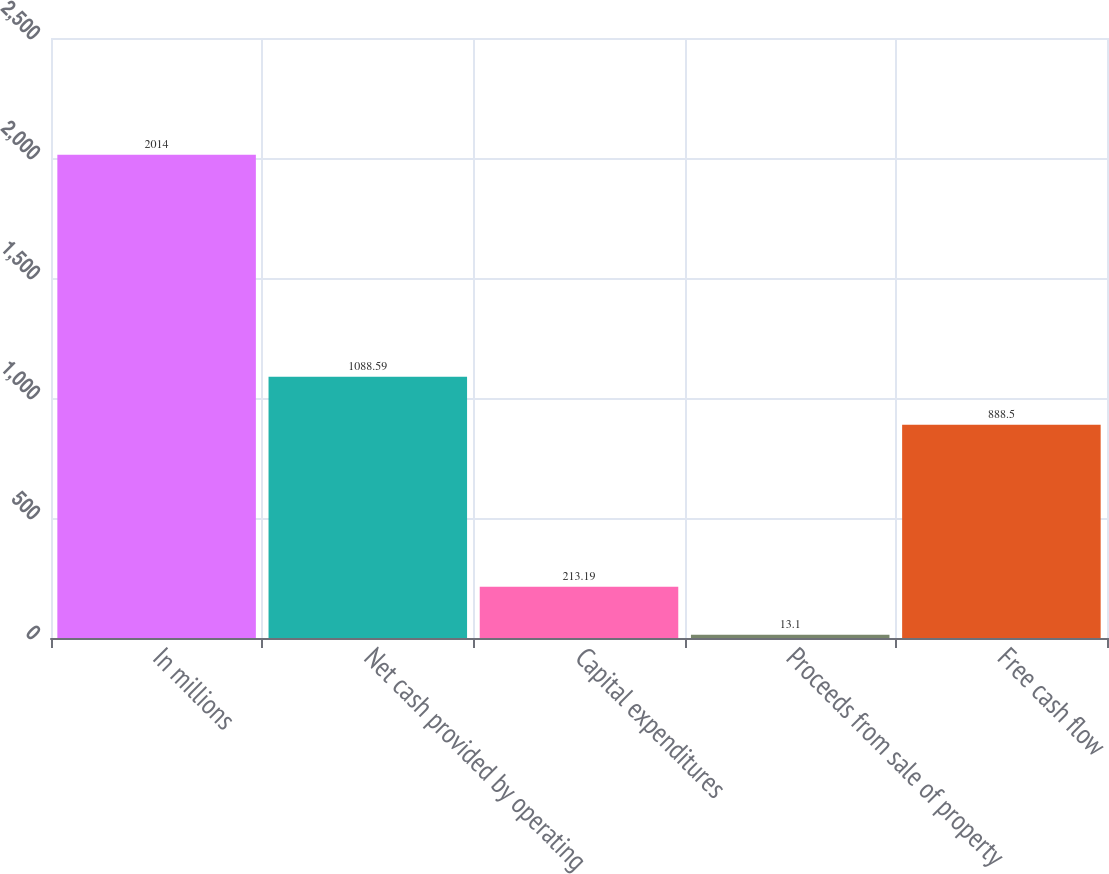Convert chart. <chart><loc_0><loc_0><loc_500><loc_500><bar_chart><fcel>In millions<fcel>Net cash provided by operating<fcel>Capital expenditures<fcel>Proceeds from sale of property<fcel>Free cash flow<nl><fcel>2014<fcel>1088.59<fcel>213.19<fcel>13.1<fcel>888.5<nl></chart> 